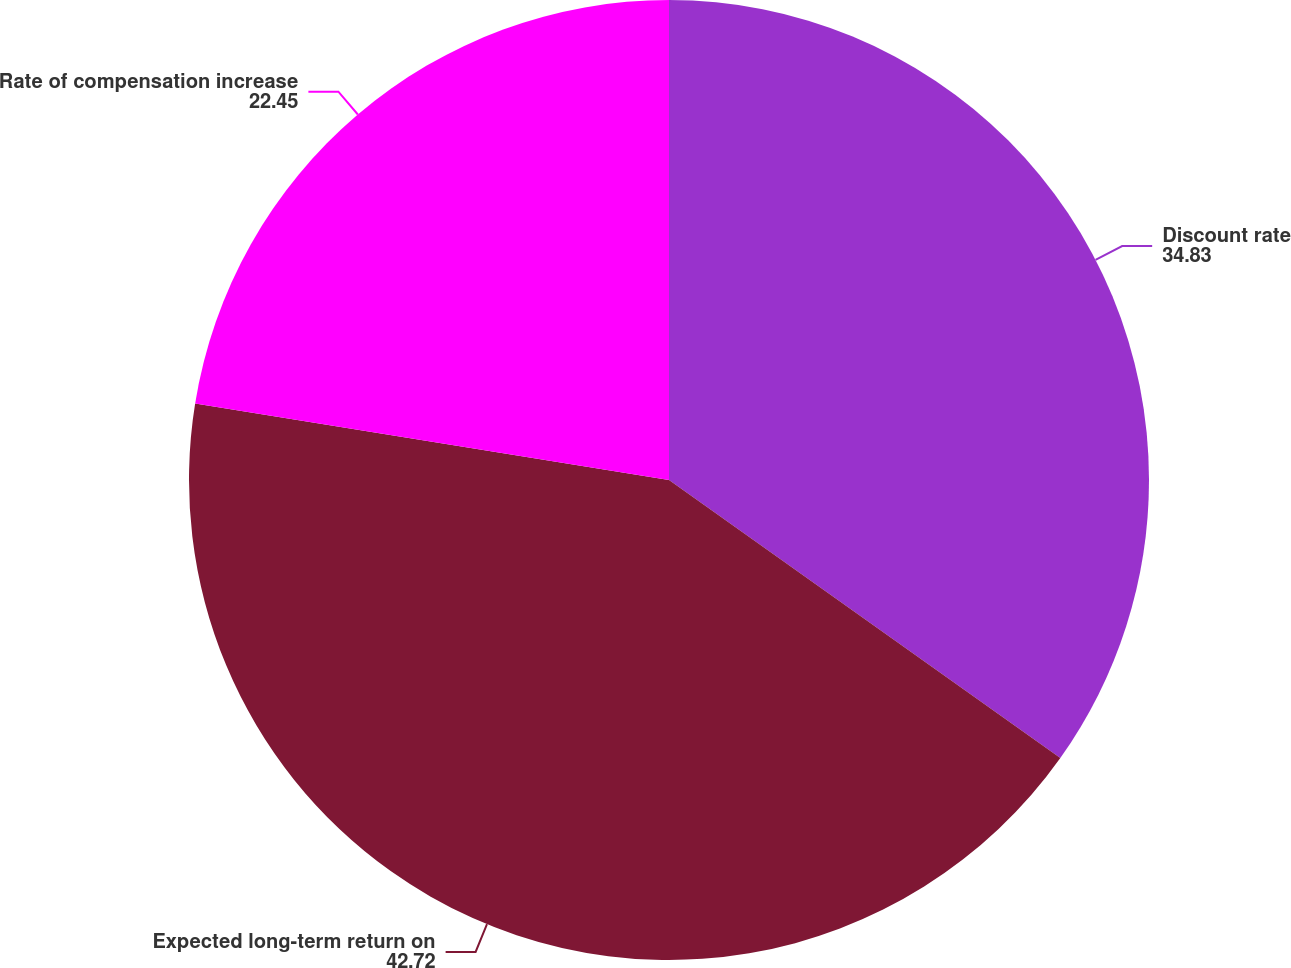Convert chart. <chart><loc_0><loc_0><loc_500><loc_500><pie_chart><fcel>Discount rate<fcel>Expected long-term return on<fcel>Rate of compensation increase<nl><fcel>34.83%<fcel>42.72%<fcel>22.45%<nl></chart> 